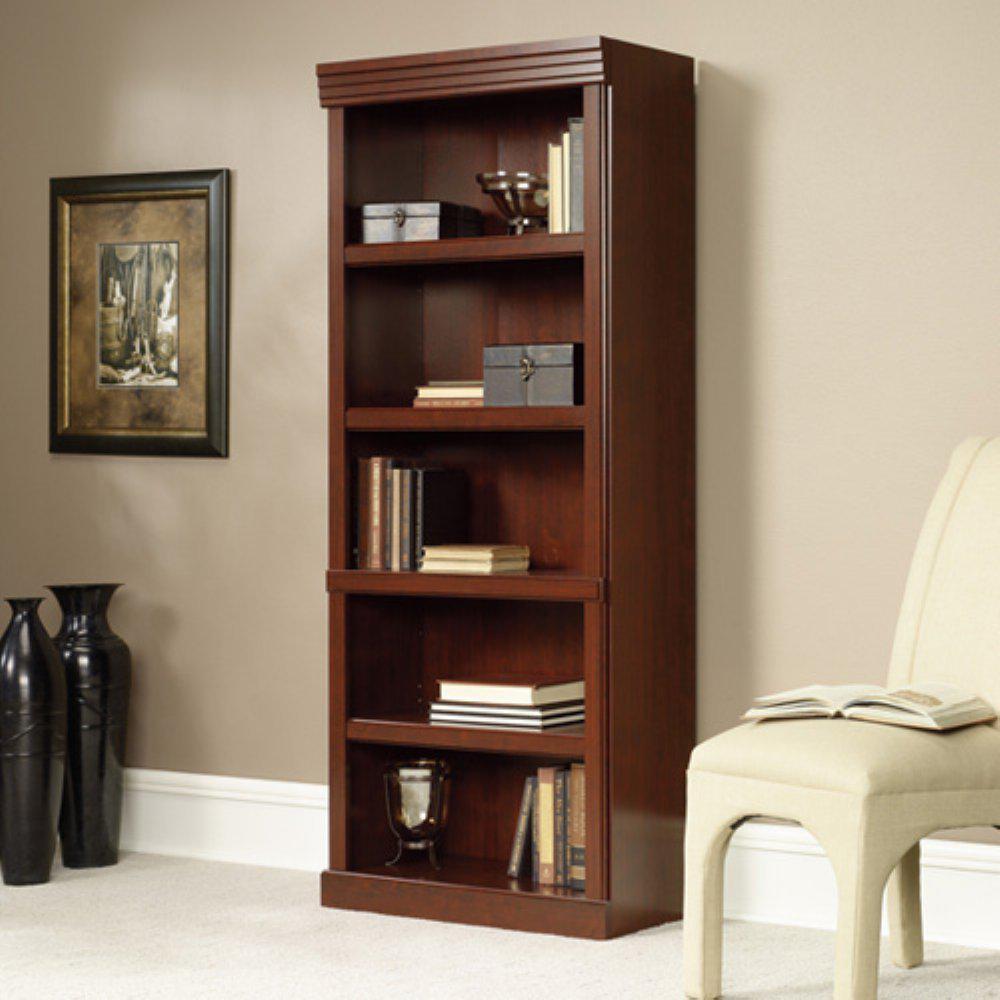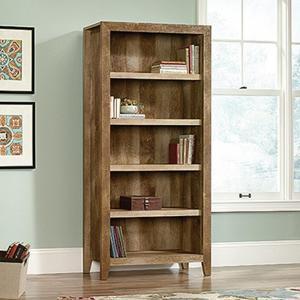The first image is the image on the left, the second image is the image on the right. Examine the images to the left and right. Is the description "One tall narrow bookcase is on short legs and one is flush to the floor." accurate? Answer yes or no. Yes. 